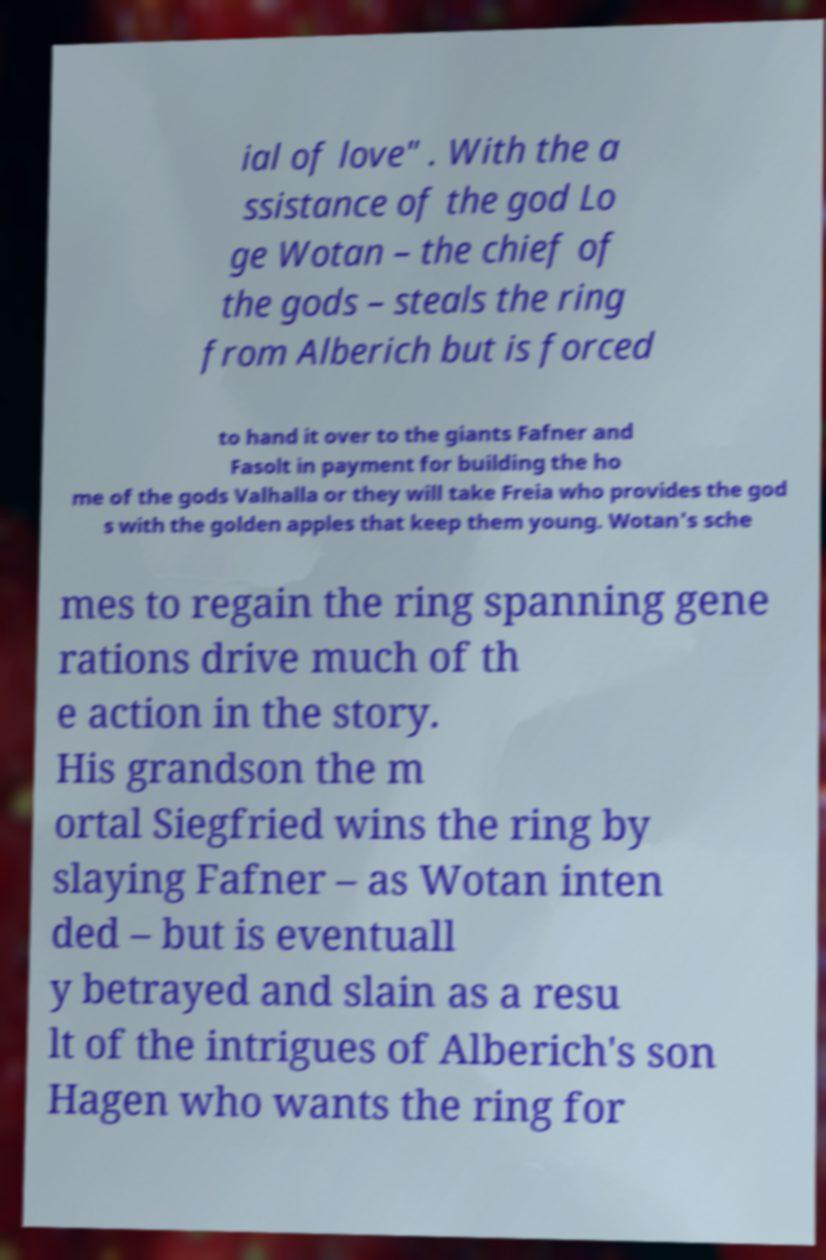Can you read and provide the text displayed in the image?This photo seems to have some interesting text. Can you extract and type it out for me? ial of love" . With the a ssistance of the god Lo ge Wotan – the chief of the gods – steals the ring from Alberich but is forced to hand it over to the giants Fafner and Fasolt in payment for building the ho me of the gods Valhalla or they will take Freia who provides the god s with the golden apples that keep them young. Wotan's sche mes to regain the ring spanning gene rations drive much of th e action in the story. His grandson the m ortal Siegfried wins the ring by slaying Fafner – as Wotan inten ded – but is eventuall y betrayed and slain as a resu lt of the intrigues of Alberich's son Hagen who wants the ring for 